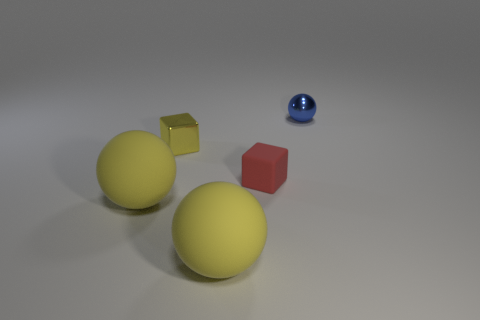Are there any red matte objects of the same size as the blue metallic ball? While there is a red object present, it is not the same size as the blue metallic ball. The red object is a cube that is smaller in scale compared to the blue sphere. The objects have distinct shapes and sizes, giving the scene a varied visual composition. 